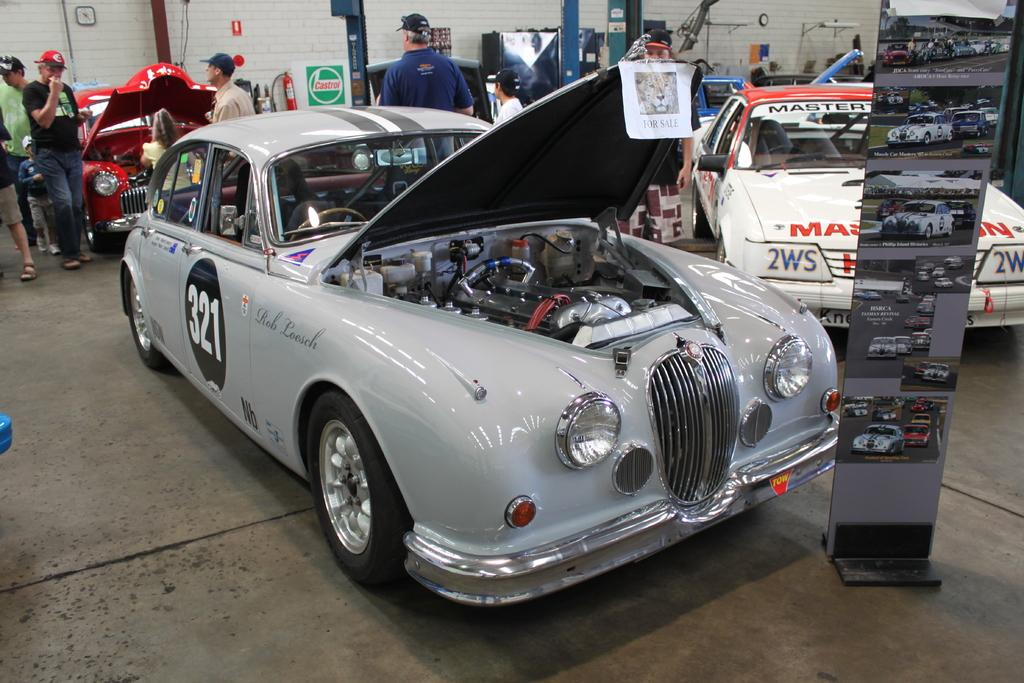What types of objects can be seen in the image? There are vehicles, people, boards, a fire extension on a wall, and other objects in the image. Can you describe the people in the image? Some people are wearing caps in the image. What is the purpose of the boards in the image? The purpose of the boards in the image is not clear from the provided facts. Where is the fire extension located in the image? The fire extension is on a wall in the image. What type of paste is being used by the people in the image? There is no paste visible in the image. Can you describe the snakes in the image? There are no snakes present in the image. 